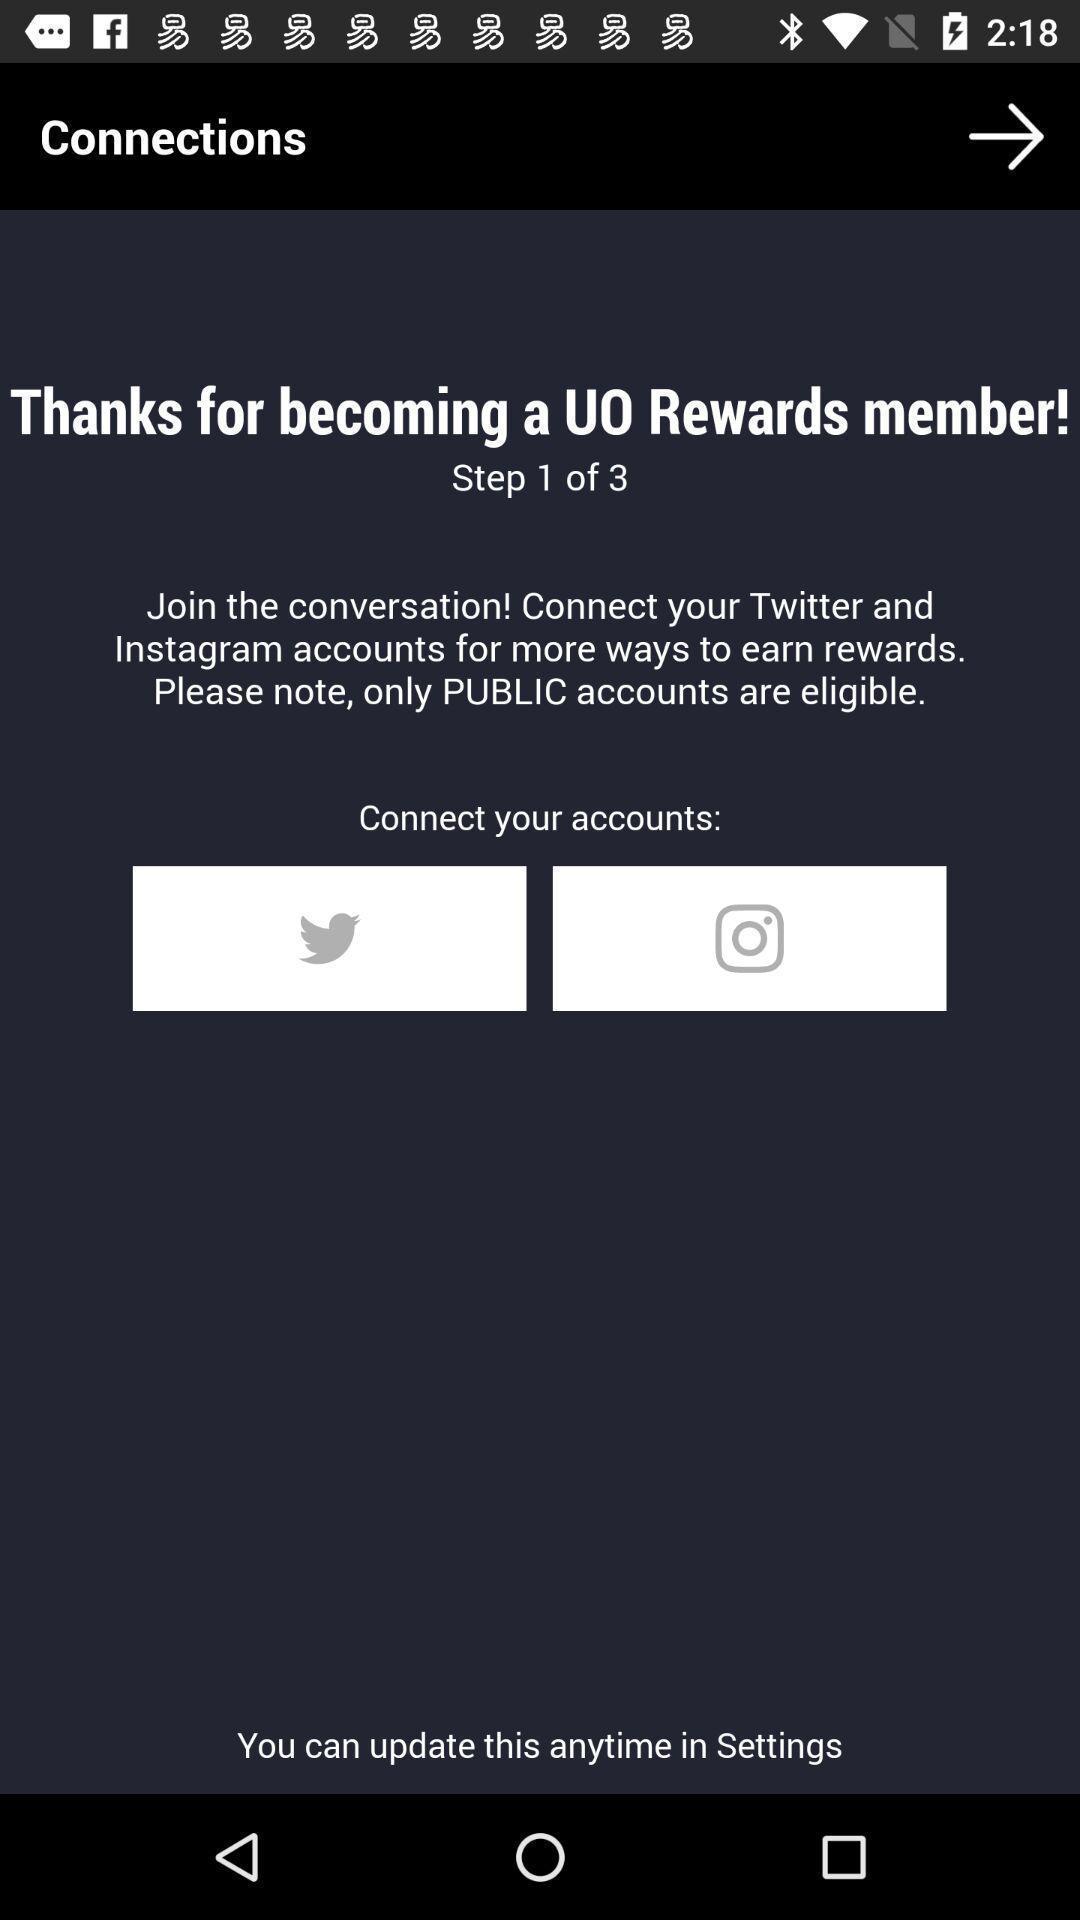Describe this image in words. Screen showing multiple social apps to connect your account. 